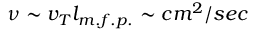<formula> <loc_0><loc_0><loc_500><loc_500>\nu \sim v _ { T } l _ { m . f . p . } \sim c m ^ { 2 } / s e c</formula> 